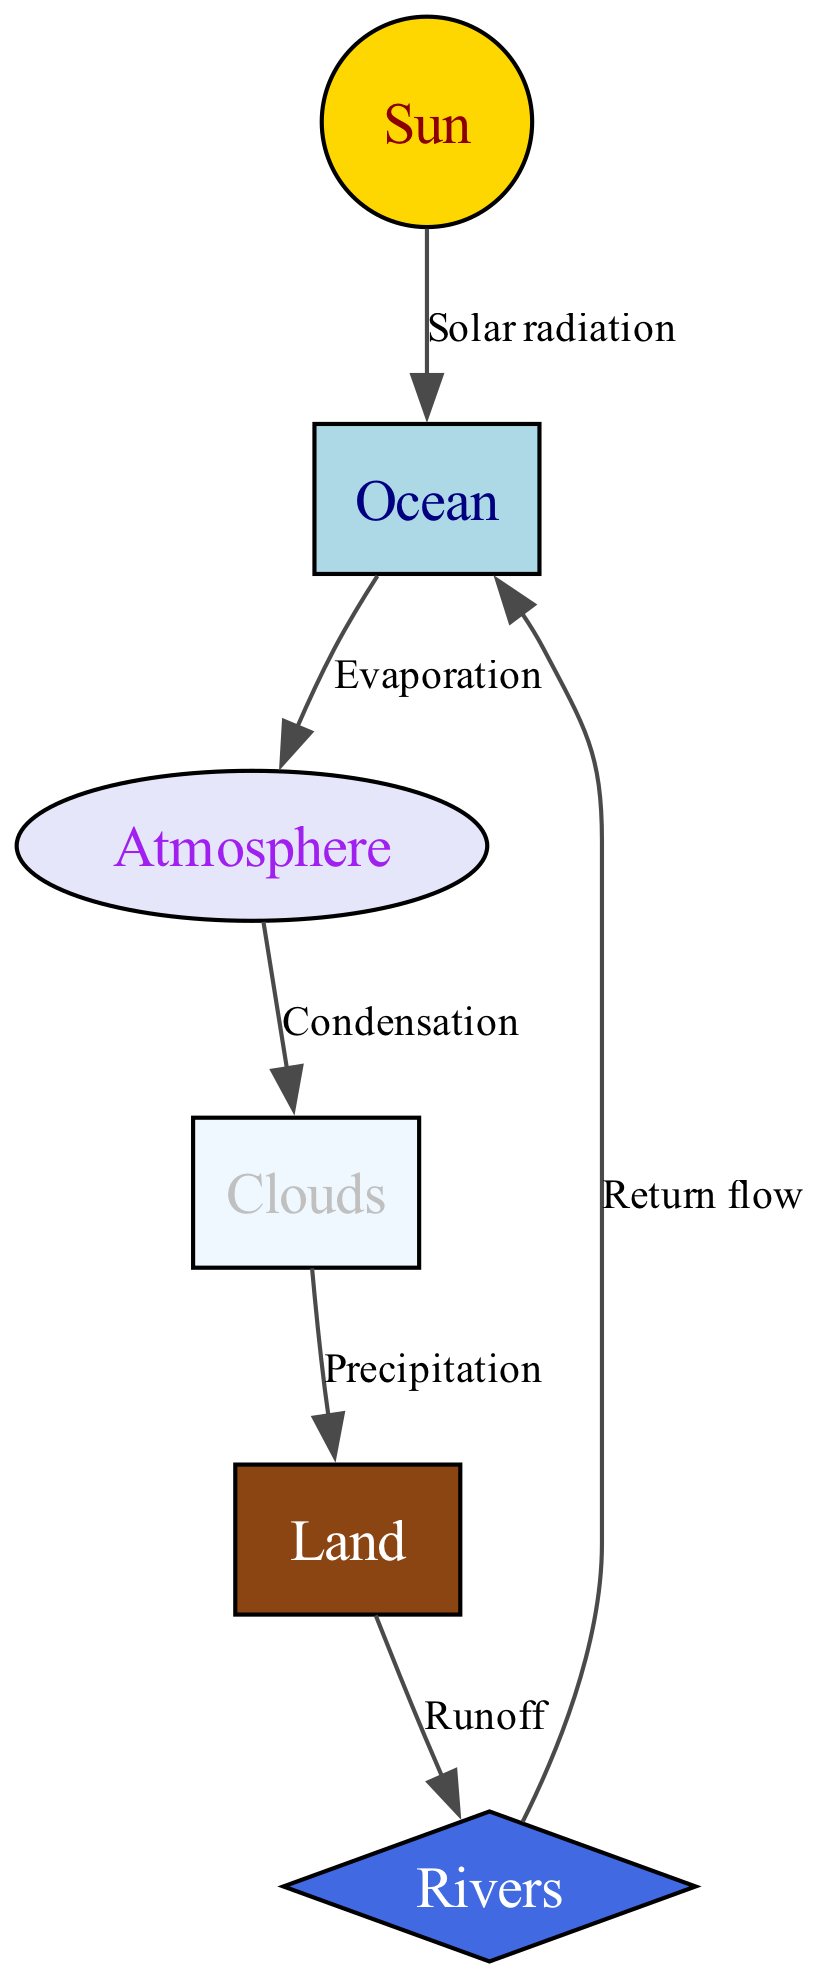What is the first element in the water cycle process? The first element is the "Sun," which initiates the water cycle process through solar radiation.
Answer: Sun How many nodes are present in the diagram? There are six nodes in the diagram: Ocean, Sun, Atmosphere, Clouds, Land, and Rivers.
Answer: 6 What process is represented by the edge from the Ocean to the Atmosphere? The process is "Evaporation," where water is vaporized from the ocean surface into the atmosphere.
Answer: Evaporation Which node receives precipitation according to the diagram? The node that receives precipitation is the "Land," represented as the destination of the precipitation flow from the clouds.
Answer: Land What role do Clouds play in relation to the Atmosphere? Clouds serve as a result of "Condensation" from the water vapor in the atmosphere, indicating that they are formed when water vapor condenses into droplets.
Answer: Condensation What is the connection between Rivers and the Ocean? The Rivers connect back to the Ocean through "Return flow," indicating how water returns to the ocean from rivers after runoff.
Answer: Return flow How does water from the Land get to Rivers? Water from the Land moves to Rivers through the process of "Runoff," which collects water and directs it into rivers.
Answer: Runoff What is the relationship between the Clouds and the Land in this diagram? The relationship is established through "Precipitation," where clouds release water onto the land, thereby completing part of the water cycle.
Answer: Precipitation Which element is directly influenced by Solar radiation in the diagram? The element directly influenced by Solar radiation is the "Ocean," which absorbs the sun's energy leading to evaporation.
Answer: Ocean 